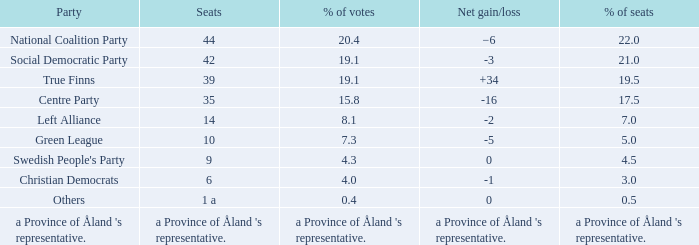When there was a net gain/loss of +34, what was the percentage of seats that party held? 19.5. 